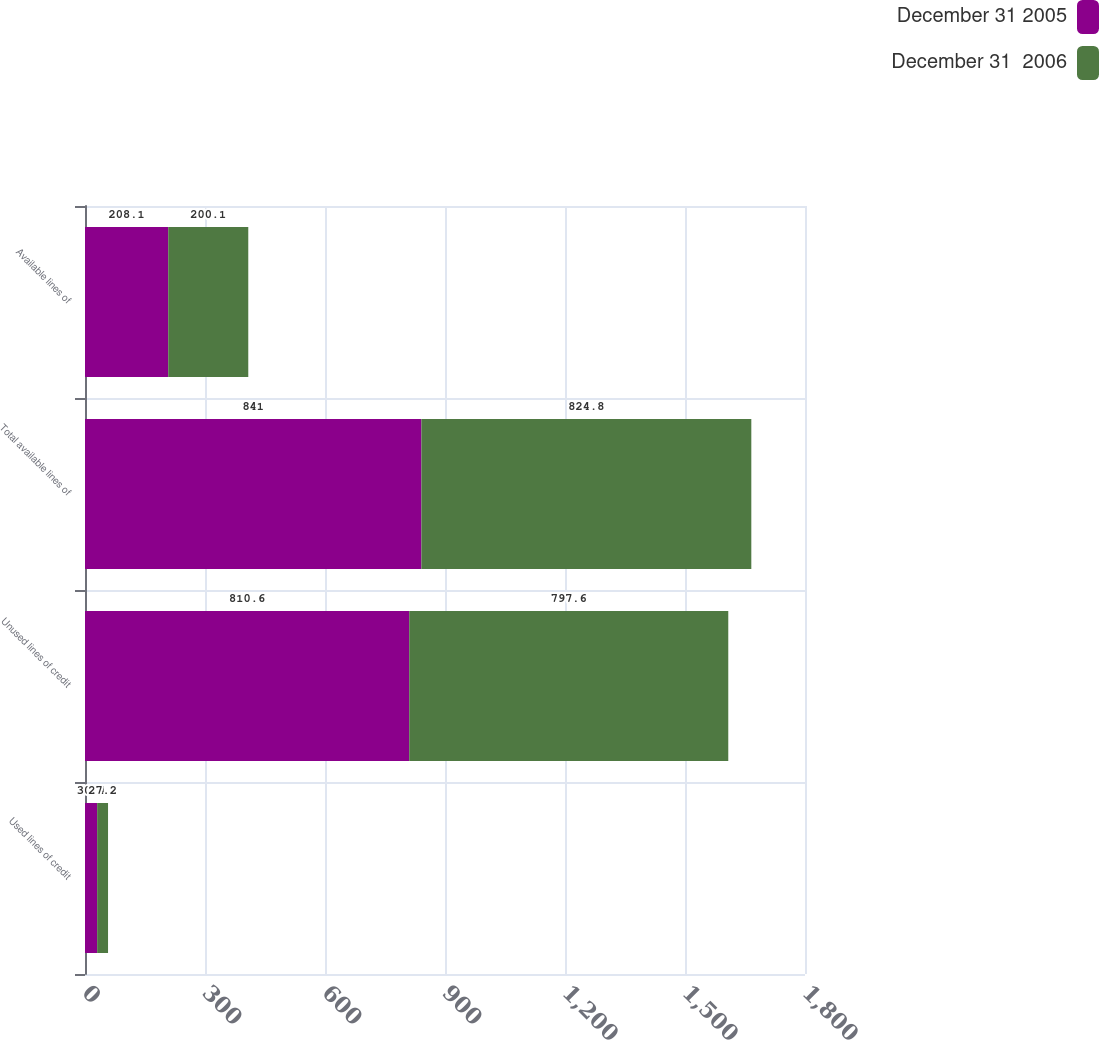Convert chart to OTSL. <chart><loc_0><loc_0><loc_500><loc_500><stacked_bar_chart><ecel><fcel>Used lines of credit<fcel>Unused lines of credit<fcel>Total available lines of<fcel>Available lines of<nl><fcel>December 31 2005<fcel>30.4<fcel>810.6<fcel>841<fcel>208.1<nl><fcel>December 31  2006<fcel>27.2<fcel>797.6<fcel>824.8<fcel>200.1<nl></chart> 